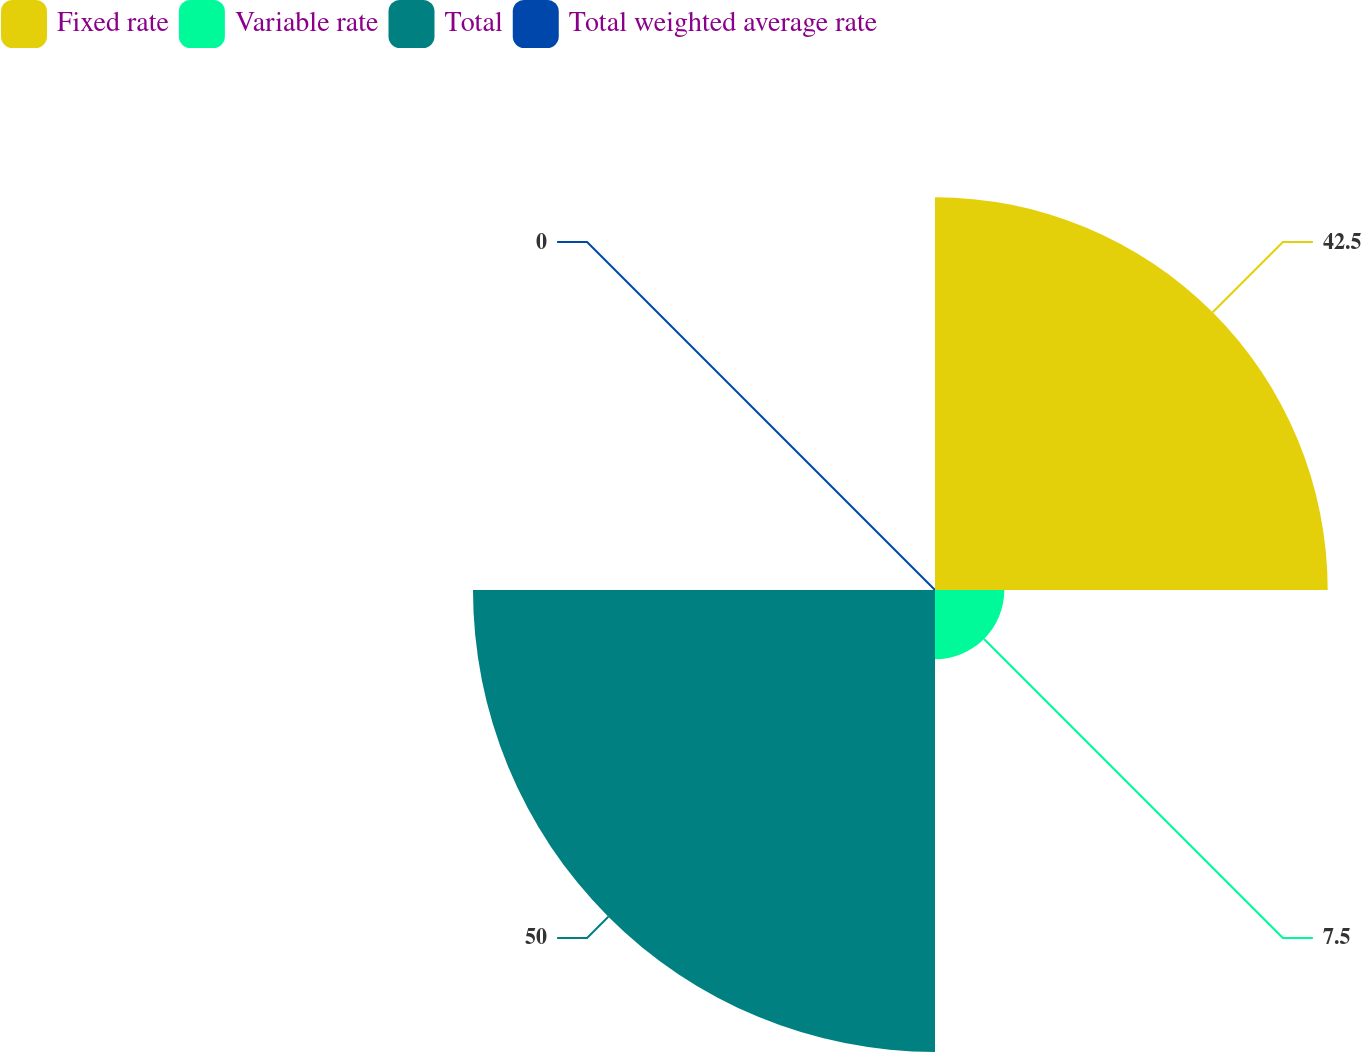Convert chart. <chart><loc_0><loc_0><loc_500><loc_500><pie_chart><fcel>Fixed rate<fcel>Variable rate<fcel>Total<fcel>Total weighted average rate<nl><fcel>42.5%<fcel>7.5%<fcel>50.0%<fcel>0.0%<nl></chart> 